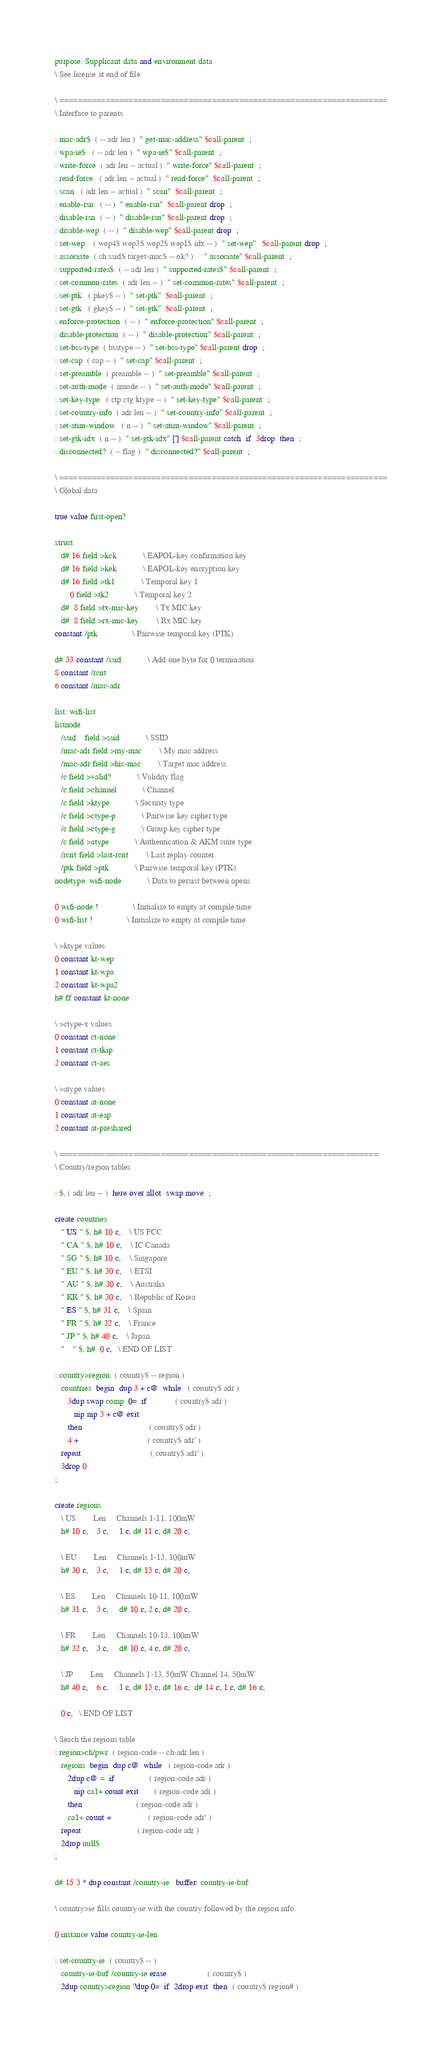<code> <loc_0><loc_0><loc_500><loc_500><_Forth_>purpose: Supplicant data and environment data
\ See license at end of file

\ =======================================================================
\ Interface to parents

: mac-adr$  ( -- adr len )  " get-mac-address" $call-parent  ;
: wpa-ie$   ( -- adr len )  " wpa-ie$" $call-parent  ;
: write-force  ( adr len -- actual )  " write-force" $call-parent  ;
: read-force   ( adr len -- actual )  " read-force"  $call-parent  ;
: scan   ( adr len -- actual )  " scan"  $call-parent  ;
: enable-rsn   ( -- )  " enable-rsn"  $call-parent drop  ;
: disable-rsn  ( -- )  " disable-rsn" $call-parent drop  ;
: disable-wep  ( -- )  " disable-wep" $call-parent drop  ;
: set-wep    ( wep4$ wep3$ wep2$ wep1$ idx -- )  " set-wep"   $call-parent drop  ;
: associate  ( ch ssid$ target-mac$ -- ok? )     " associate" $call-parent  ;
: supported-rates$  ( -- adr len )  " supported-rates$" $call-parent  ;
: set-common-rates  ( adr len -- )  " set-common-rates" $call-parent  ;
: set-ptk   ( pkey$ -- )  " set-ptk"  $call-parent  ;
: set-gtk   ( gkey$ -- )  " set-gtk"  $call-parent  ;
: enforce-protection  ( -- )  " enforce-protection" $call-parent  ;
: disable-protection  ( -- )  " disable-protection" $call-parent  ;
: set-bss-type  ( bsstype -- )  " set-bss-type" $call-parent drop  ;
: set-cap  ( cap -- )  " set-cap" $call-parent  ;
: set-preamble  ( preamble -- )  " set-preamble" $call-parent  ;
: set-auth-mode  ( amode -- )  " set-auth-mode" $call-parent  ;
: set-key-type   ( ctp ctg ktype -- )  " set-key-type" $call-parent  ;
: set-country-info  ( adr len -- )  " set-country-info" $call-parent  ;
: set-atim-window   ( n -- )  " set-atim-window" $call-parent  ;
: set-gtk-idx  ( n -- )  " set-gtk-idx" ['] $call-parent catch  if  3drop  then  ;
: disconnected?  ( -- flag )  " disconnected?" $call-parent  ;

\ =======================================================================
\ Global data

true value first-open?

struct
   d# 16 field >kck			\ EAPOL-key confirmation key
   d# 16 field >kek			\ EAPOL-key encryption key
   d# 16 field >tk1			\ Temporal key 1
       0 field >tk2			\ Temporal key 2
   d#  8 field >tx-mic-key		\ Tx MIC key
   d#  8 field >rx-mic-key		\ Rx MIC key
constant /ptk				\ Pairwise temporal key (PTK)

d# 33 constant /ssid			\ Add one byte for 0 termination
8 constant /rcnt
6 constant /mac-adr

list: wifi-list
listnode
   /ssid    field >ssid			\ SSID
   /mac-adr field >my-mac		\ My mac address
   /mac-adr field >his-mac		\ Target mac address
   /c field >valid?			\ Validity flag
   /c field >channel			\ Channel
   /c field >ktype			\ Security type
   /c field >ctype-p			\ Pairwise key cipher type
   /c field >ctype-g			\ Group key cipher type
   /c field >atype			\ Authentication & AKM suite type
   /rcnt field >last-rcnt		\ Last replay counter
   /ptk field >ptk			\ Pairwise temporal key (PTK)
nodetype: wifi-node			\ Data to persist between opens

0 wifi-node !				\ Initialize to empty at compile time
0 wifi-list !				\ Initialize to empty at compile time

\ >ktype values
0 constant kt-wep
1 constant kt-wpa
2 constant kt-wpa2
h# ff constant kt-none

\ >ctype-x values
0 constant ct-none
1 constant ct-tkip
2 constant ct-aes

\ >atype values
0 constant at-none
1 constant at-eap
2 constant at-preshared

\ =====================================================================
\ Country/region tables

: $, ( adr len -- )  here over allot  swap move  ;

create countries
   " US " $, h# 10 c,	\ US FCC
   " CA " $, h# 10 c,	\ IC Canada
   " SG " $, h# 10 c,	\ Singapore
   " EU " $, h# 30 c,	\ ETSI
   " AU " $, h# 30 c,	\ Australia
   " KR " $, h# 30 c,	\ Republic of Korea
   " ES " $, h# 31 c,	\ Spain
   " FR " $, h# 32 c,	\ France
   " JP " $, h# 40 c,	\ Japan
   "    " $, h#  0 c,   \ END OF LIST

: country>region  ( country$ -- region )
   countries  begin  dup 3 + c@  while   ( country$ adr )
      3dup swap comp  0=  if             ( country$ adr )
         nip nip 3 + c@ exit
      then                               ( country$ adr )
      4 +                                ( country$ adr' )
   repeat                                ( country$ adr' )
   3drop 0
;

create regions
   \ US        Len   	Channels 1-11, 100mW
   h# 10 c,    3 c,     1 c, d# 11 c, d# 20 c,	

   \ EU        Len 	Channels 1-13, 100mW
   h# 30 c,    3 c,     1 c, d# 13 c, d# 20 c,

   \ ES        Len 	Channels 10-11, 100mW
   h# 31 c,    3 c,     d# 10 c, 2 c, d# 20 c,

   \ FR        Len 	Channels 10-13, 100mW
   h# 32 c,    3 c,     d# 10 c, 4 c, d# 20 c,

   \ JP        Len 	Channels 1-13, 50mW	Channel 14, 50mW
   h# 40 c,    6 c,     1 c, d# 13 c, d# 16 c,  d# 14 c, 1 c, d# 16 c,	

   0 c,   \ END OF LIST

\ Seach the regions table
: region>ch/pwr  ( region-code -- ch-adr,len )
   regions  begin  dup c@  while   ( region-code adr )
      2dup c@ =  if                ( region-code adr )
         nip ca1+ count exit       ( region-code adr )
      then                         ( region-code adr )
      ca1+ count +                 ( region-code adr' )
   repeat                          ( region-code adr )
   2drop null$
;

d# 15 3 * dup constant /country-ie   buffer: country-ie-buf

\ country>ie fills country-ie with the country followed by the region info

0 instance value country-ie-len

: set-country-ie  ( country$ -- )
   country-ie-buf /country-ie erase                   ( country$ )
   2dup country>region ?dup 0=  if  2drop exit  then  ( country$ region# )</code> 